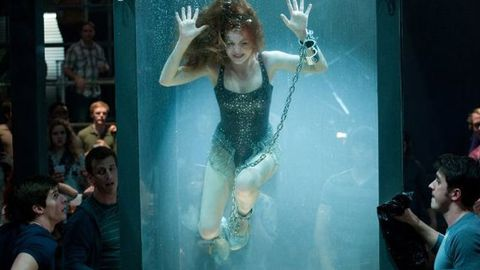Can you describe the emotion captured in this image? The image conveys tension and suspense. The focus is on the performer's face, which appears serene amidst the potential danger, adding to the overall drama. The audience’s facial expressions range from concern to amazement, reflecting the high stakes of the performance. What themes can be drawn from this image? This scene touches on themes of courage, overcoming adversity, and the will to surpass human limitations. It also plays with the concept of spectacle in entertainment, where danger and the potential for failure are part of the allure. The act of escapology itself symbolizes breaking free from constraints, both metaphorical and literal. 